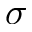Convert formula to latex. <formula><loc_0><loc_0><loc_500><loc_500>\sigma</formula> 